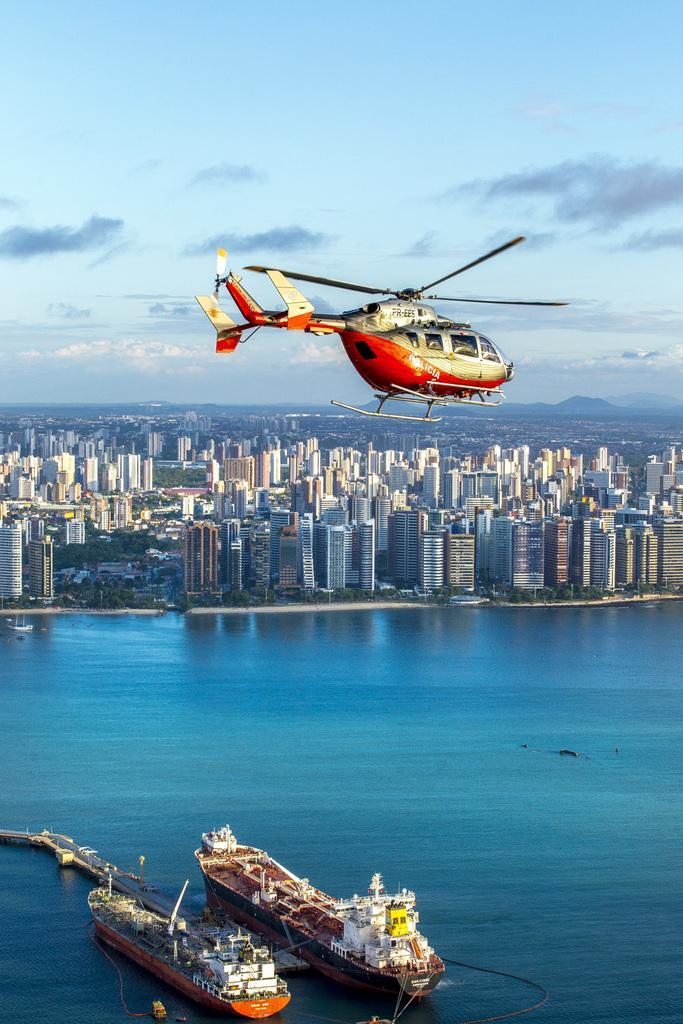How would you summarize this image in a sentence or two? In the picture I can see an helicopter is flying in the air, I can see two ships are floating in the water, I can see tower buildings, trees, hills and the cloudy sky in the background. 